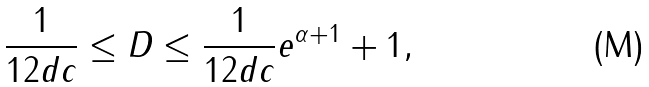<formula> <loc_0><loc_0><loc_500><loc_500>\frac { 1 } { 1 2 d c } \leq D \leq \frac { 1 } { 1 2 d c } { e ^ { \alpha + 1 } + 1 } ,</formula> 